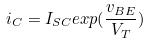Convert formula to latex. <formula><loc_0><loc_0><loc_500><loc_500>i _ { C } = I _ { S C } e x p ( \frac { v _ { B E } } { V _ { T } } )</formula> 